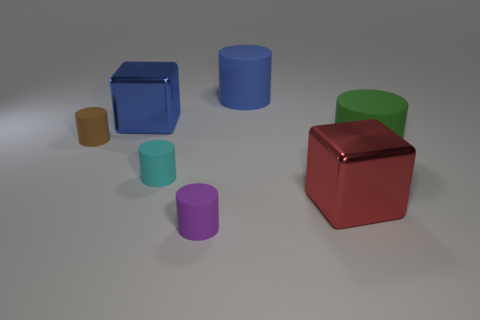Add 2 small purple things. How many objects exist? 9 Subtract all large cylinders. How many cylinders are left? 3 Subtract all green cylinders. How many cylinders are left? 4 Subtract 2 cubes. How many cubes are left? 0 Add 2 cyan cylinders. How many cyan cylinders are left? 3 Add 2 small metal cubes. How many small metal cubes exist? 2 Subtract 1 blue cylinders. How many objects are left? 6 Subtract all cylinders. How many objects are left? 2 Subtract all purple blocks. Subtract all purple cylinders. How many blocks are left? 2 Subtract all gray spheres. How many purple cylinders are left? 1 